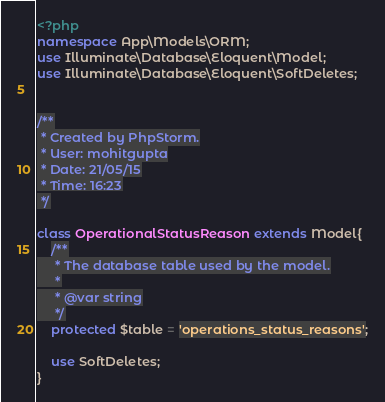<code> <loc_0><loc_0><loc_500><loc_500><_PHP_><?php
namespace App\Models\ORM;
use Illuminate\Database\Eloquent\Model;
use Illuminate\Database\Eloquent\SoftDeletes;


/**
 * Created by PhpStorm.
 * User: mohitgupta
 * Date: 21/05/15
 * Time: 16:23
 */

class OperationalStatusReason extends Model{
    /**
     * The database table used by the model.
     *
     * @var string
     */
    protected $table = 'operations_status_reasons';

    use SoftDeletes;
}</code> 